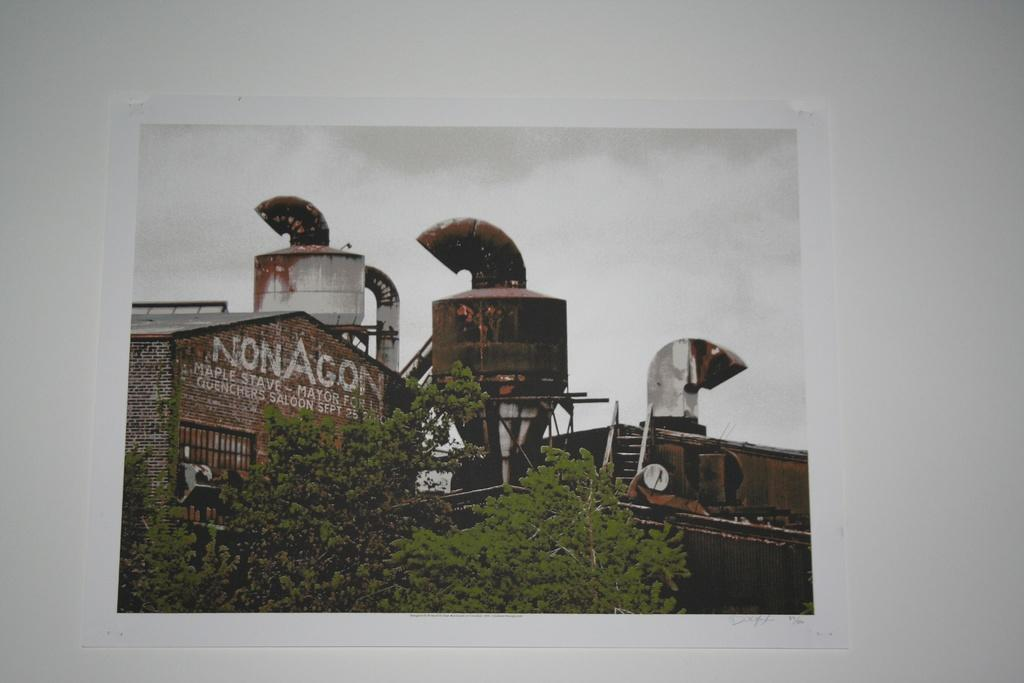<image>
Describe the image concisely. A run down NonAgon factory sits under a gloomy sky. 